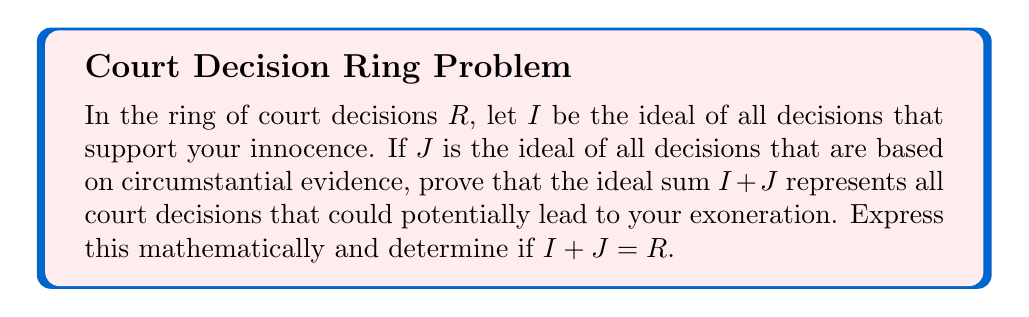What is the answer to this math problem? Let's approach this step-by-step:

1) In ring theory, an ideal $I$ of a ring $R$ is a subset of $R$ that is closed under addition and multiplication by any element of $R$.

2) The ideal sum $I + J$ is defined as:
   $I + J = \{i + j \mid i \in I, j \in J\}$

3) In our context:
   - $I$ represents decisions supporting innocence
   - $J$ represents decisions based on circumstantial evidence

4) The sum $I + J$ would represent decisions that are either:
   a) Supporting innocence directly
   b) Based on circumstantial evidence
   c) A combination of both

5) Mathematically, we can express this as:
   $\forall d \in (I + J), \exists i \in I, j \in J : d = i + j$

6) This means any decision in $I + J$ could potentially lead to exoneration because:
   - Direct support of innocence could lead to exoneration
   - Circumstantial evidence could be challenged or reinterpreted
   - A combination of both provides multiple avenues for defense

7) To determine if $I + J = R$, we need to consider if there are any court decisions that are neither supportive of innocence nor based on circumstantial evidence.

8) In a fair judicial system, all decisions should be based on either direct evidence (which would support guilt or innocence) or circumstantial evidence.

9) Therefore, any decision $d \in R$ should be expressible as $d = i + j$ where $i \in I$ and $j \in J$.

10) This implies that $I + J = R$.
Answer: $I + J = R$ 